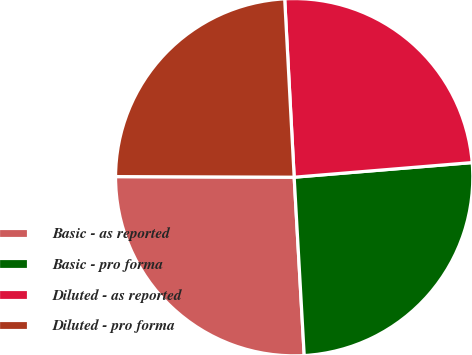Convert chart. <chart><loc_0><loc_0><loc_500><loc_500><pie_chart><fcel>Basic - as reported<fcel>Basic - pro forma<fcel>Diluted - as reported<fcel>Diluted - pro forma<nl><fcel>25.95%<fcel>25.41%<fcel>24.54%<fcel>24.1%<nl></chart> 